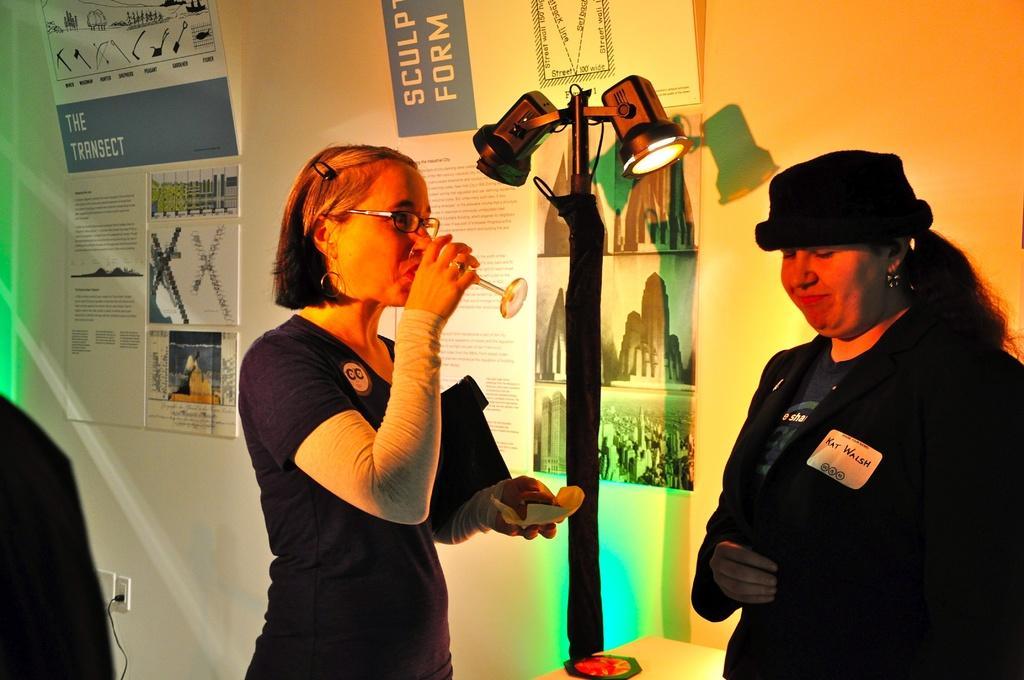Describe this image in one or two sentences. In this picture we can see there are two women standing and a woman is holding a glass and some objects. Behind the women, there is a stand with lights attached to it. Behind the stand, there are some posters attached to a wall. On the left side of the woman there is a cable. 